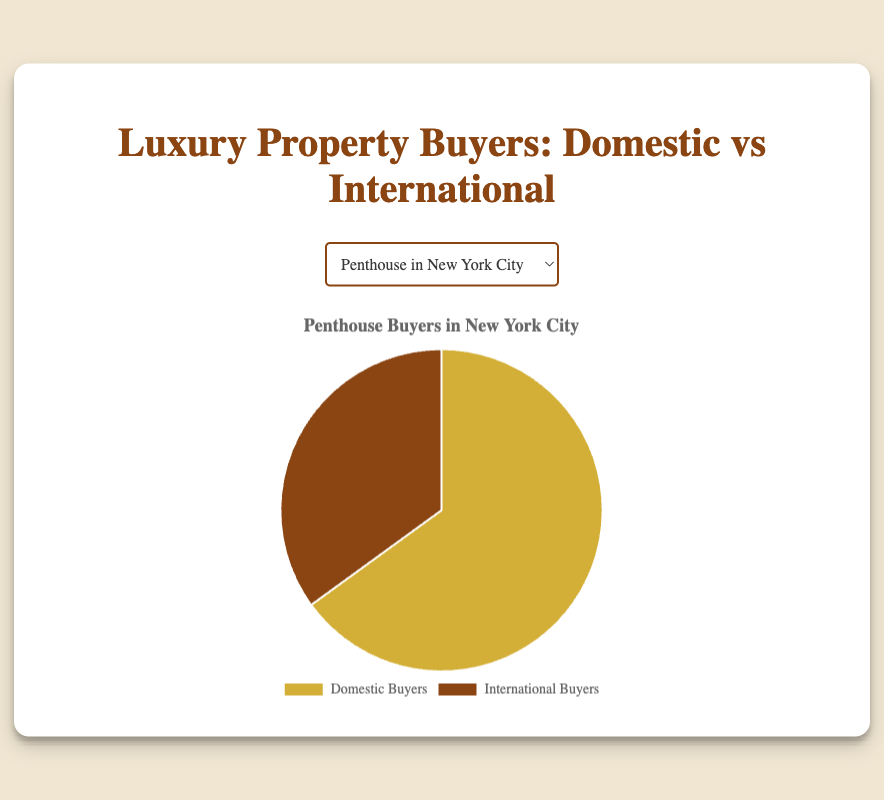What is the proportion of domestic buyers for the Luxury Apartment in London? The pie chart for the Luxury Apartment in London shows two segments where the domestic buyers' segment makes up 40% of the whole pie.
Answer: 40% Which property has the highest proportion of international buyers? Comparing the pie charts for each property, the Mansion in Dubai has the largest segment dedicated to international buyers, which is 80%.
Answer: Mansion in Dubai For the Estate in Los Angeles, which group of buyers forms the larger proportion? The pie chart for the Estate in Los Angeles shows domestic buyers occupy a larger segment (60%) compared to international buyers (40%).
Answer: Domestic buyers How does the proportion of international buyers of the Penthouse in New York City compare to the international buyers of the Chateau in Provence? The pie charts indicate that the Penthouse in New York City has 35% international buyers, while the Chateau in Provence has 70% international buyers, making the latter significantly larger.
Answer: The Chateau in Provence has a larger proportion of international buyers Which property shows an equal proportion of domestic and international buyers? The pie chart for the Luxury Condo in Singapore depicts two equal segments, representing 50% domestic buyers and 50% international buyers.
Answer: Luxury Condo in Singapore What is the combined proportion of domestic buyers across the Estate in Los Angeles and the Beachfront Villa in Miami? The pie chart shows 60% domestic buyers for the Estate in Los Angeles and 55% for the Beachfront Villa in Miami. Adding these up gives a combined proportion of 115%.
Answer: 115% If you were to pick properties where domestic buyers make up the minority, which properties would these be? From the pie charts, the properties where domestic buyers are less than 50% are the Chateau in Provence (30% domestic), Luxury Apartment in London (40% domestic), and Mansion in Dubai (20% domestic).
Answer: Chateau in Provence, Luxury Apartment in London, and Mansion in Dubai How does the proportion of domestic buyers for the Penthouse in New York City compare to the Beachfront Villa in Miami? The pie chart shows the domestic buyers for the Penthouse in New York City at 65% and for the Beachfront Villa in Miami at 55%, indicating that the former has a higher proportion.
Answer: The Penthouse in New York City has a higher proportion of domestic buyers For any property, what is the difference in proportions between domestic and international buyers if they are unequal? Let's take the Beachfront Villa in Miami as an example, where the domestic buyers are 55% and international buyers are 45%. The difference is computed as 55% - 45% = 10%.
Answer: 10% Which property is the closest to having an even split between domestic and international buyers but not exactly? The Luxury Apartment in London shows domestic buyers at 40% and international buyers at 60%, which is the closest to an even split without being exactly equal.
Answer: Luxury Apartment in London 